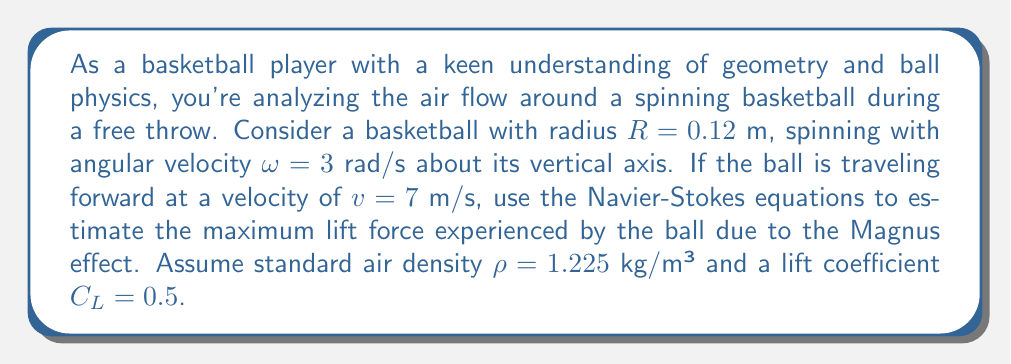Could you help me with this problem? To solve this problem, we'll use a simplified version of the Navier-Stokes equations, focusing on the lift force generated by the Magnus effect. The steps are as follows:

1) The Magnus effect creates a lift force perpendicular to both the direction of motion and the axis of rotation. For a basketball spinning about its vertical axis and moving horizontally, this force will be horizontal and perpendicular to the direction of motion.

2) The lift force due to the Magnus effect can be approximated using the equation:

   $$F_L = \frac{1}{2} C_L \rho A v^2$$

   Where:
   - $F_L$ is the lift force
   - $C_L$ is the lift coefficient
   - $\rho$ is the air density
   - $A$ is the cross-sectional area of the ball
   - $v$ is the relative velocity between the ball's surface and the air

3) The cross-sectional area of the basketball is:

   $$A = \pi R^2 = \pi (0.12 \text{ m})^2 = 0.0452 \text{ m}^2$$

4) The relative velocity between the ball's surface and the air is the sum of the forward velocity and the tangential velocity due to rotation:

   $$v = v_{\text{forward}} + \omega R = 7 \text{ m/s} + (3 \text{ rad/s})(0.12 \text{ m}) = 7.36 \text{ m/s}$$

5) Now we can substitute all values into the lift force equation:

   $$F_L = \frac{1}{2} (0.5) (1.225 \text{ kg/m}³) (0.0452 \text{ m}^2) (7.36 \text{ m/s})^2$$

6) Calculating the result:

   $$F_L = 0.5 \cdot 1.225 \cdot 0.0452 \cdot 54.1696 = 1.50 \text{ N}$$

Thus, the maximum lift force experienced by the ball due to the Magnus effect is approximately 1.50 N.
Answer: The maximum lift force experienced by the spinning basketball due to the Magnus effect is approximately 1.50 N. 